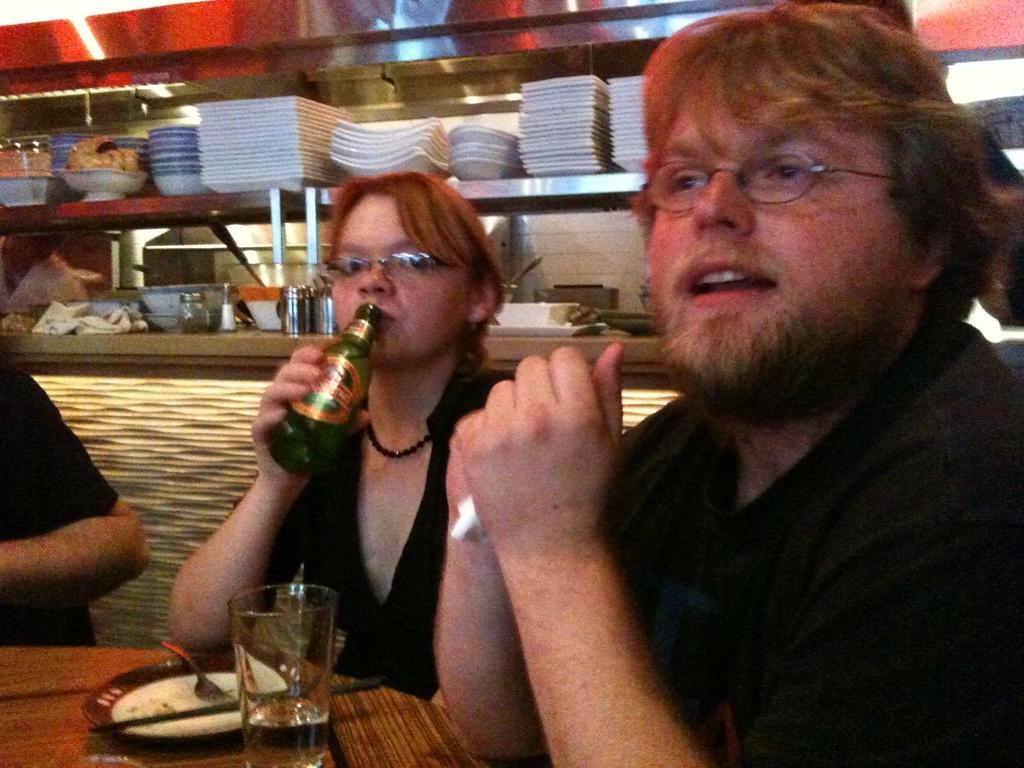Please provide a concise description of this image. In this image we can see two persons and among them a person is holding a bottle. On the left side we can see a person truncated. Behind the persons we can see a group of objects in the shelves. At the bottom we can see few objects on a surface. 